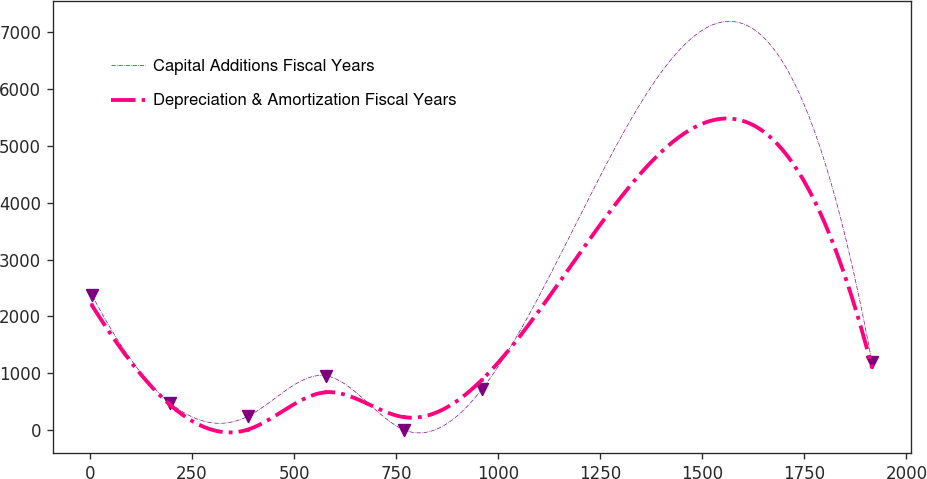Convert chart to OTSL. <chart><loc_0><loc_0><loc_500><loc_500><line_chart><ecel><fcel>Capital Additions Fiscal Years<fcel>Depreciation & Amortization Fiscal Years<nl><fcel>4.63<fcel>2382.1<fcel>2197.09<nl><fcel>195.76<fcel>479.18<fcel>445.09<nl><fcel>386.89<fcel>241.31<fcel>7.09<nl><fcel>578.02<fcel>954.92<fcel>664.09<nl><fcel>769.15<fcel>3.44<fcel>226.09<nl><fcel>960.28<fcel>717.05<fcel>883.09<nl><fcel>1915.89<fcel>1192.79<fcel>1102.09<nl></chart> 